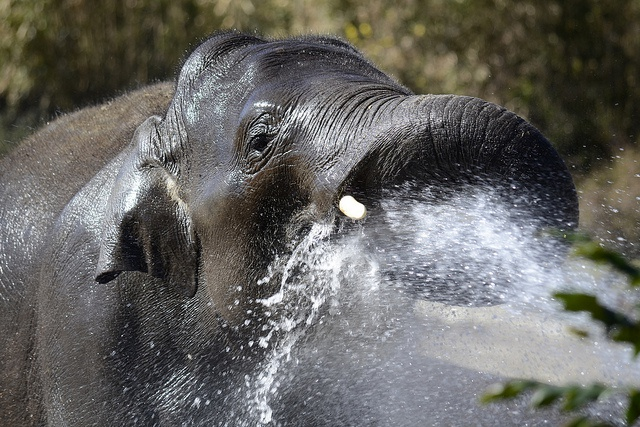Describe the objects in this image and their specific colors. I can see a elephant in olive, gray, black, darkgray, and lightgray tones in this image. 